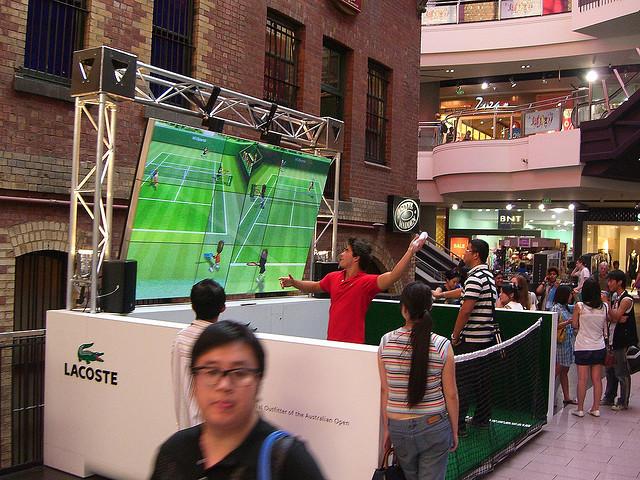What game is being played?
Concise answer only. Tennis. What animal is portrayed above Lacoste?
Concise answer only. Alligator. What company makes the video game?
Be succinct. Lacoste. 